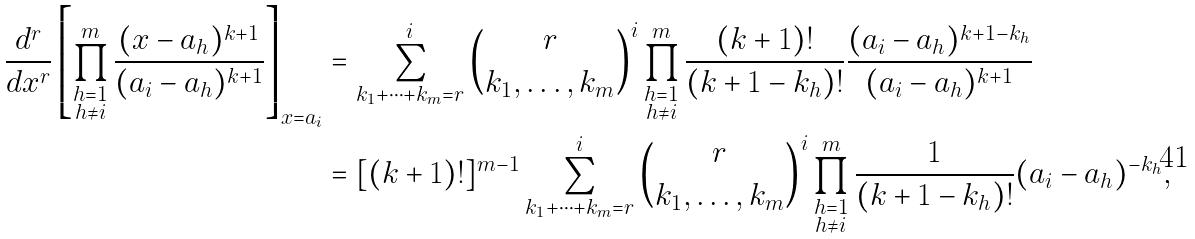Convert formula to latex. <formula><loc_0><loc_0><loc_500><loc_500>\frac { d ^ { r } } { d x ^ { r } } \left [ \prod ^ { m } _ { \substack { h = 1 \\ h \neq i } } \frac { ( x - a _ { h } ) ^ { k + 1 } } { ( a _ { i } - a _ { h } ) ^ { k + 1 } } \right ] _ { x = a _ { i } } & = \sum _ { k _ { 1 } + \dots + k _ { m } = r } ^ { i } \binom { r } { k _ { 1 } , \dots , k _ { m } } ^ { i } \prod _ { \substack { h = 1 \\ h \neq i } } ^ { m } \frac { ( k + 1 ) ! } { ( k + 1 - k _ { h } ) ! } \frac { ( a _ { i } - a _ { h } ) ^ { k + 1 - k _ { h } } } { ( a _ { i } - a _ { h } ) ^ { k + 1 } } \\ & = [ ( k + 1 ) ! ] ^ { m - 1 } \sum _ { k _ { 1 } + \dots + k _ { m } = r } ^ { i } \binom { r } { k _ { 1 } , \dots , k _ { m } } ^ { i } \prod _ { \substack { h = 1 \\ h \neq i } } ^ { m } \frac { 1 } { ( k + 1 - k _ { h } ) ! } ( a _ { i } - a _ { h } ) ^ { - k _ { h } } ,</formula> 